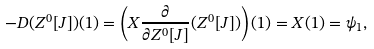Convert formula to latex. <formula><loc_0><loc_0><loc_500><loc_500>- D ( Z ^ { 0 } [ J ] ) ( 1 ) = \left ( X \frac { \partial } { \partial Z ^ { 0 } [ J ] } ( Z ^ { 0 } [ J ] ) \right ) ( 1 ) = X ( 1 ) = \psi _ { 1 } ,</formula> 